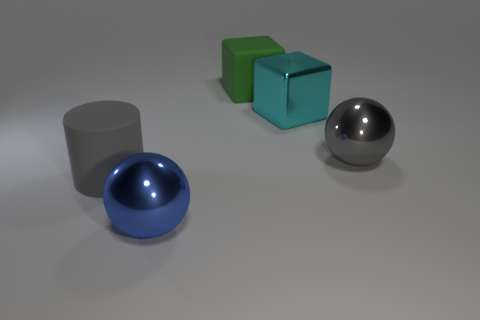What is the material of the thing that is the same color as the matte cylinder?
Offer a terse response. Metal. Are there fewer large rubber cubes than blue matte blocks?
Your answer should be compact. No. What color is the other thing that is the same shape as the cyan metal object?
Your answer should be very brief. Green. Is there any other thing that has the same shape as the blue thing?
Your answer should be compact. Yes. Is the number of large cyan metallic cylinders greater than the number of metal spheres?
Offer a terse response. No. What number of other things are made of the same material as the gray sphere?
Your response must be concise. 2. What shape is the object left of the large ball in front of the large gray thing that is on the right side of the big green object?
Give a very brief answer. Cylinder. Are there fewer large green cubes to the left of the big blue ball than big cyan metal objects that are on the left side of the large rubber cube?
Offer a very short reply. No. Are there any spheres of the same color as the big matte block?
Offer a very short reply. No. Do the cyan block and the gray thing behind the large matte cylinder have the same material?
Give a very brief answer. Yes. 